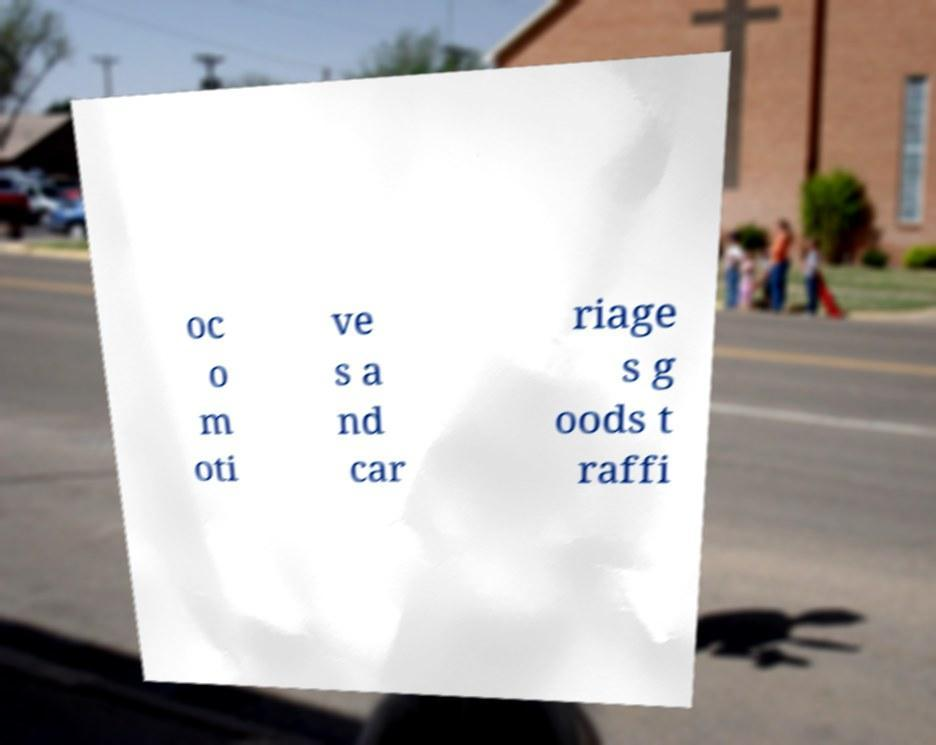I need the written content from this picture converted into text. Can you do that? oc o m oti ve s a nd car riage s g oods t raffi 